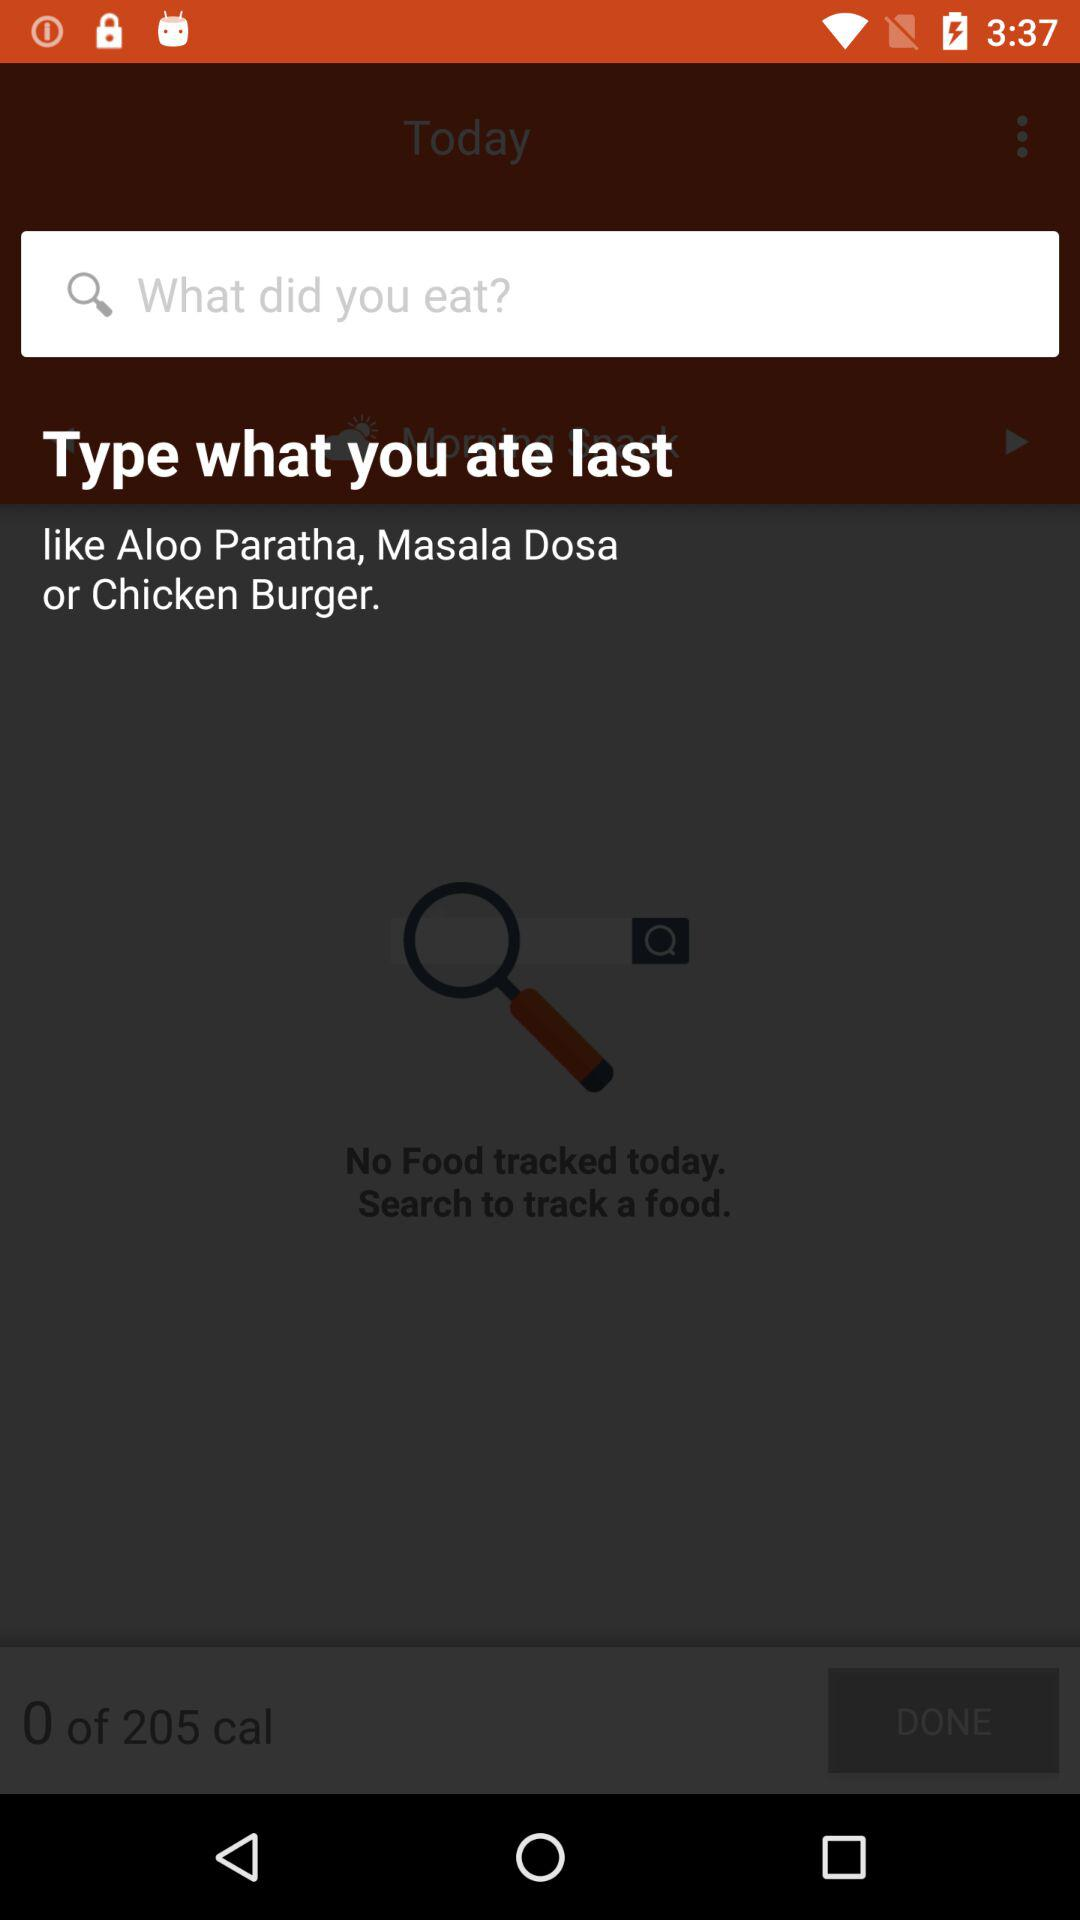How many calories are left to consume today?
Answer the question using a single word or phrase. 205 